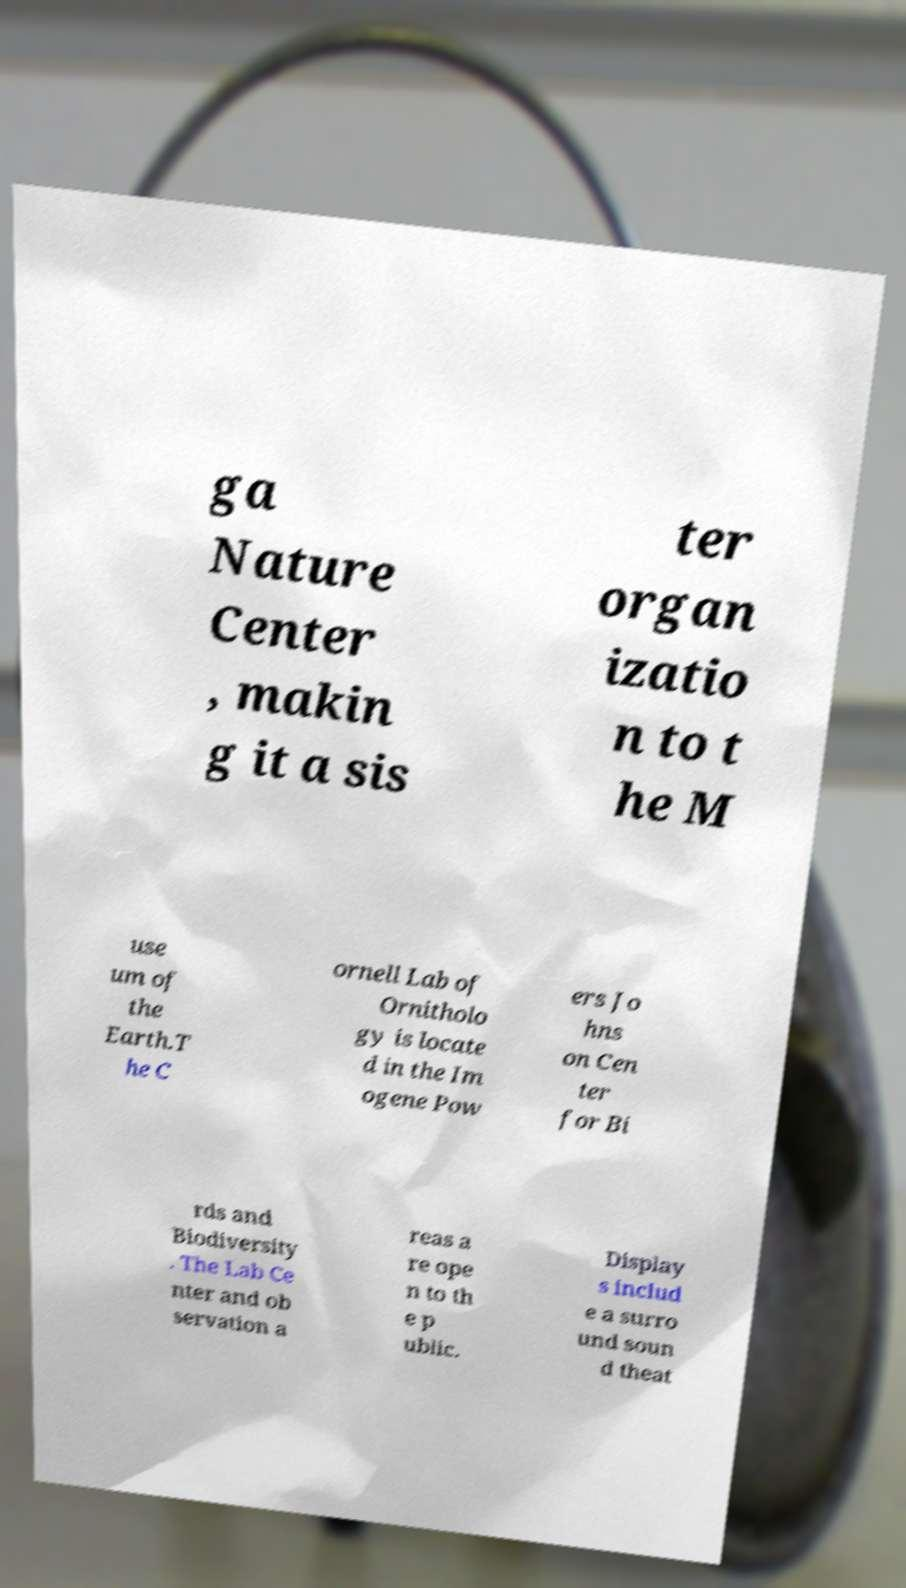Could you assist in decoding the text presented in this image and type it out clearly? ga Nature Center , makin g it a sis ter organ izatio n to t he M use um of the Earth.T he C ornell Lab of Ornitholo gy is locate d in the Im ogene Pow ers Jo hns on Cen ter for Bi rds and Biodiversity . The Lab Ce nter and ob servation a reas a re ope n to th e p ublic. Display s includ e a surro und soun d theat 